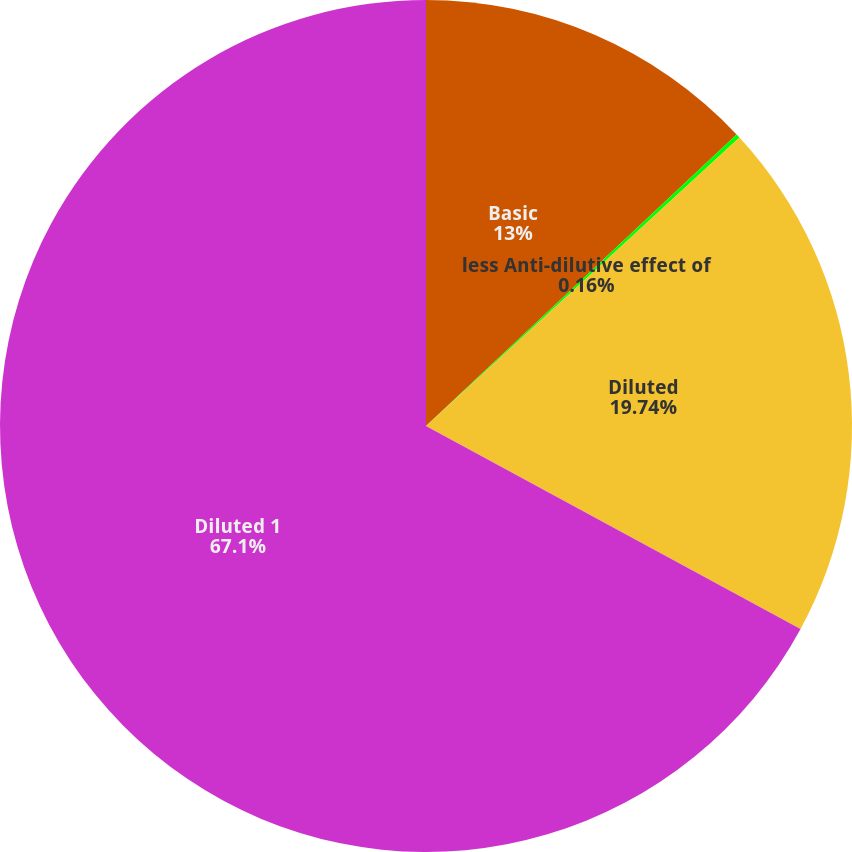Convert chart to OTSL. <chart><loc_0><loc_0><loc_500><loc_500><pie_chart><fcel>Basic<fcel>less Anti-dilutive effect of<fcel>Diluted<fcel>Diluted 1<nl><fcel>13.0%<fcel>0.16%<fcel>19.74%<fcel>67.09%<nl></chart> 